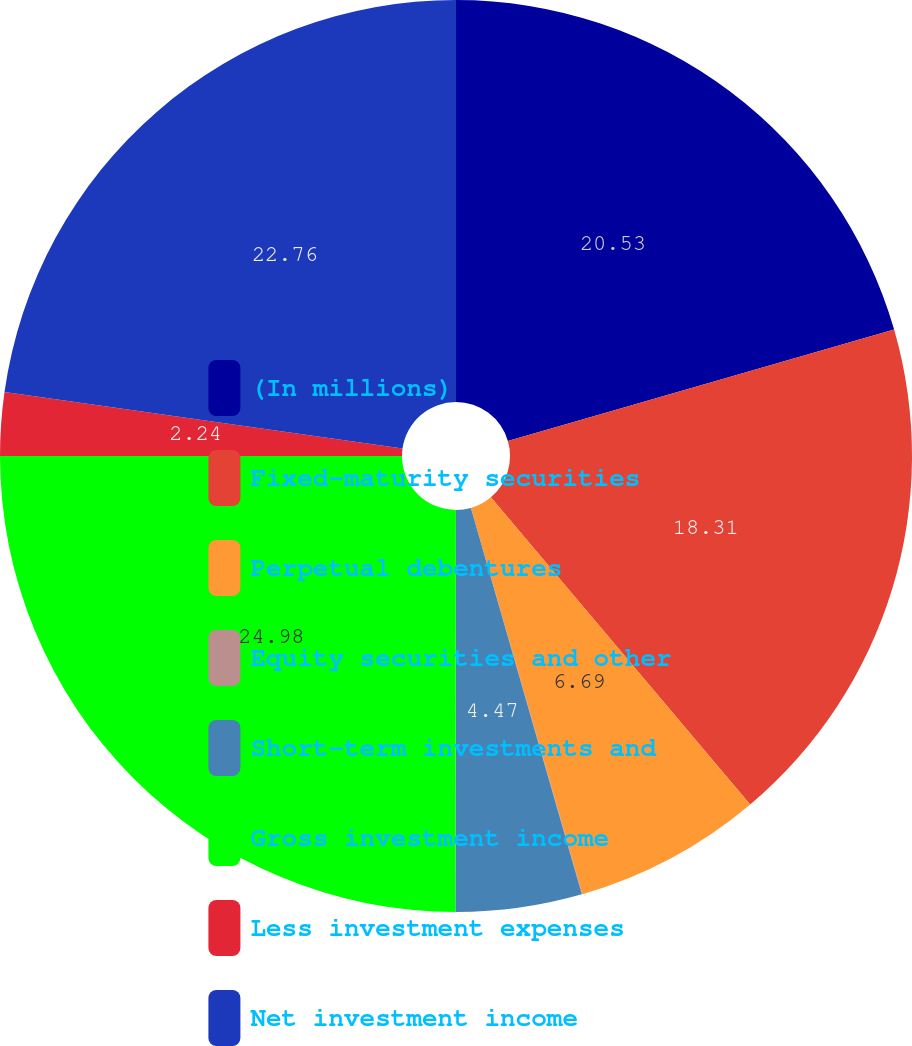Convert chart to OTSL. <chart><loc_0><loc_0><loc_500><loc_500><pie_chart><fcel>(In millions)<fcel>Fixed-maturity securities<fcel>Perpetual debentures<fcel>Equity securities and other<fcel>Short-term investments and<fcel>Gross investment income<fcel>Less investment expenses<fcel>Net investment income<nl><fcel>20.53%<fcel>18.31%<fcel>6.69%<fcel>0.02%<fcel>4.47%<fcel>24.98%<fcel>2.24%<fcel>22.76%<nl></chart> 